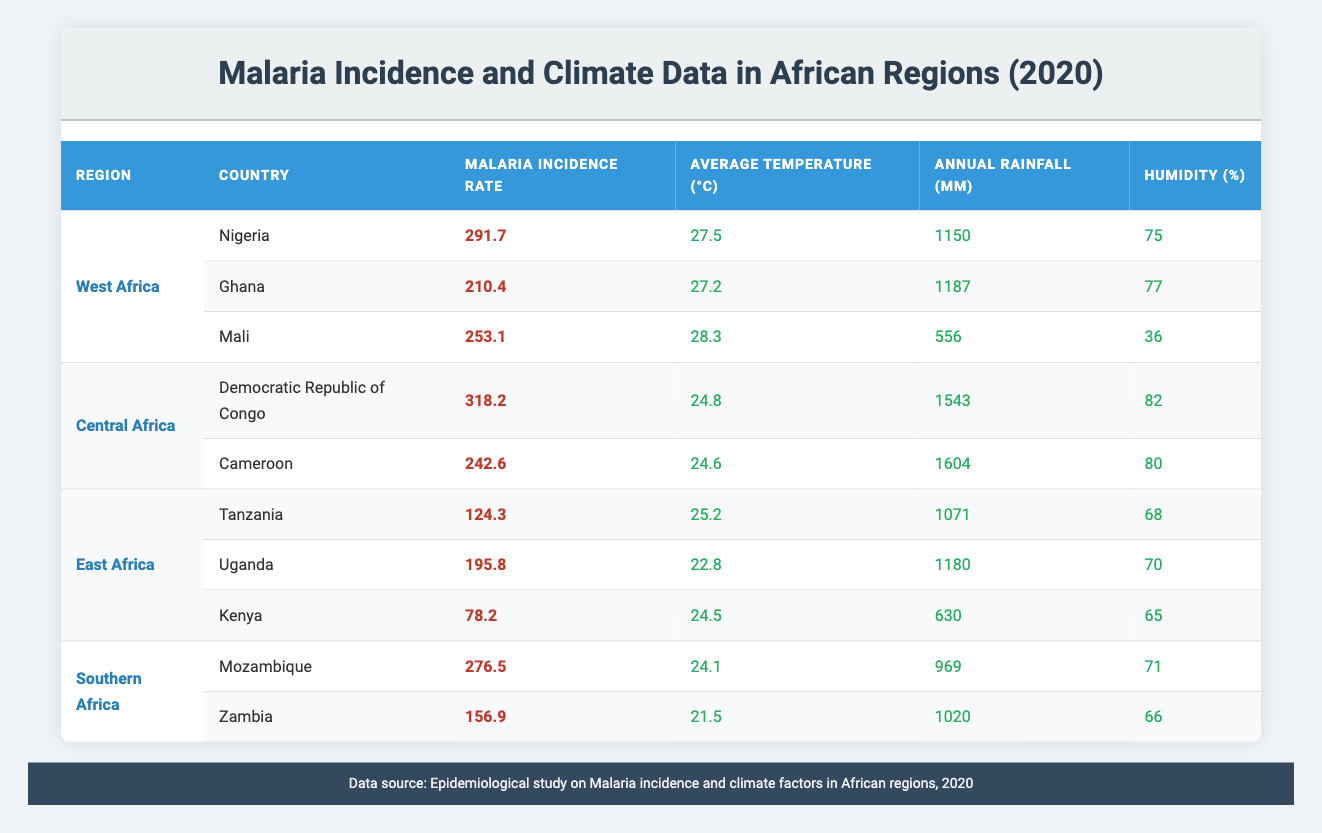What is the malaria incidence rate in Nigeria? From the table, the row for Nigeria shows a malaria incidence rate of 291.7.
Answer: 291.7 Which country in Central Africa has the highest malaria incidence rate? In the Central Africa section, Democratic Republic of Congo has the highest malaria incidence rate at 318.2, while Cameroon is lower at 242.6.
Answer: Democratic Republic of Congo What is the average temperature in East Africa represented in the table? The average temperatures for East Africa are 25.2 (Tanzania), 22.8 (Uganda), and 24.5 (Kenya). Their sum is 25.2 + 22.8 + 24.5 = 72.5, and since there are 3 countries, the average is 72.5 / 3 = 24.17.
Answer: 24.17 Is the malaria incidence rate in Ghana higher than in Zambia? Ghana's malaria incidence rate is 210.4 and Zambia's rate is 156.9. Since 210.4 is greater than 156.9, the answer is yes.
Answer: Yes What is the total annual rainfall in Central Africa? The annual rainfall data for Central Africa shows 1543 mm from the Democratic Republic of Congo and 1604 mm from Cameroon. Adding these, 1543 + 1604 = 3147 mm is the total rainfall for Central Africa.
Answer: 3147 mm Which region has the lowest average humidity based on the table? By examining the humidity values, West Africa has 75 (Nigeria), 77 (Ghana), and 36 (Mali), Central Africa has 82 (DR Congo) and 80 (Cameroon), East Africa has 68 (Tanzania), 70 (Uganda), and 65 (Kenya), Southern Africa has 71 (Mozambique) and 66 (Zambia). The lowest average humidity is thus in West Africa with a minimum of 36 for Mali.
Answer: West Africa Calculate the average malaria incidence rate across all regions. To find the average incidence rate, sum all rates: 291.7 (Nigeria) + 210.4 (Ghana) + 253.1 (Mali) + 318.2 (DR Congo) + 242.6 (Cameroon) + 124.3 (Tanzania) + 195.8 (Uganda) + 276.5 (Mozambique) + 156.9 (Zambia) + 78.2 (Kenya) = 1855.7. There are 10 countries, so the average is 1855.7 / 10 = 185.57.
Answer: 185.57 Does Zambia have a higher malaria incidence rate than Tanzania? Zambia's rate is 156.9 while Tanzania's is 124.3. Since 156.9 is greater than 124.3, the answer is yes.
Answer: Yes What is the percentage difference in malaria incidence rates between the highest and lowest recorded in the table? The highest incidence rate is 318.2 (Democratic Republic of Congo) and the lowest is 78.2 (Kenya). The difference is 318.2 - 78.2 = 240. The percentage difference is (240 / 78.2) * 100 = 306.6%.
Answer: 306.6% 